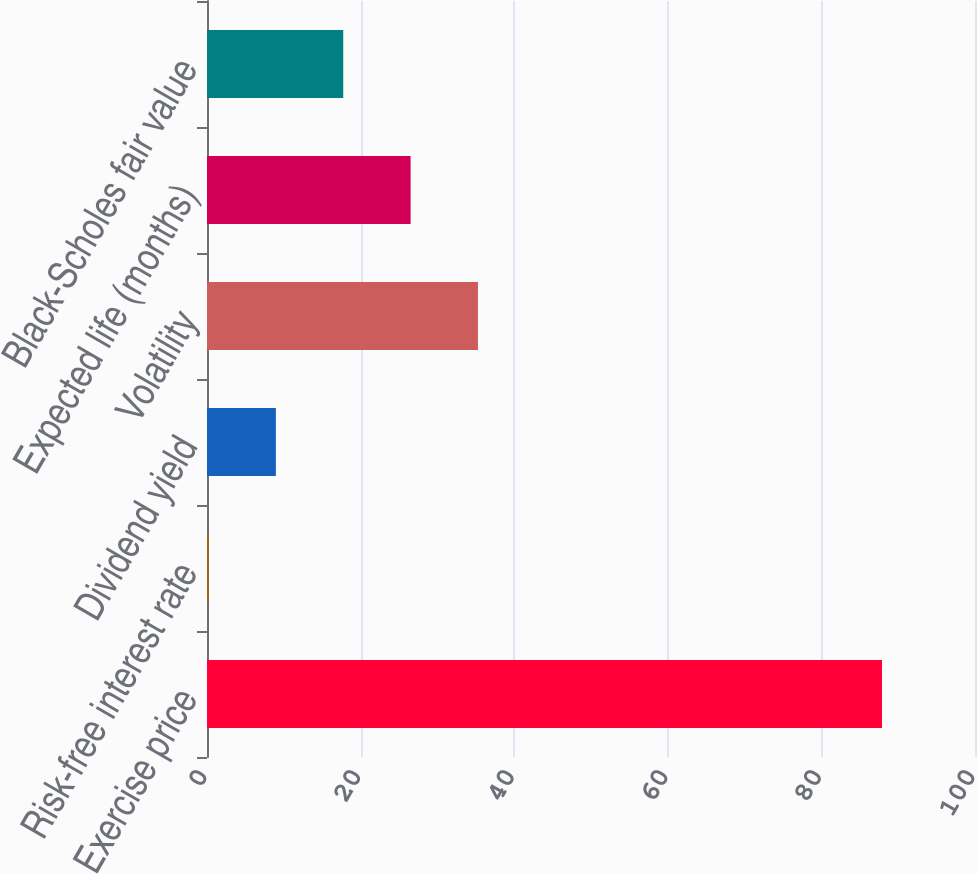Convert chart to OTSL. <chart><loc_0><loc_0><loc_500><loc_500><bar_chart><fcel>Exercise price<fcel>Risk-free interest rate<fcel>Dividend yield<fcel>Volatility<fcel>Expected life (months)<fcel>Black-Scholes fair value<nl><fcel>87.89<fcel>0.2<fcel>8.97<fcel>35.28<fcel>26.51<fcel>17.74<nl></chart> 